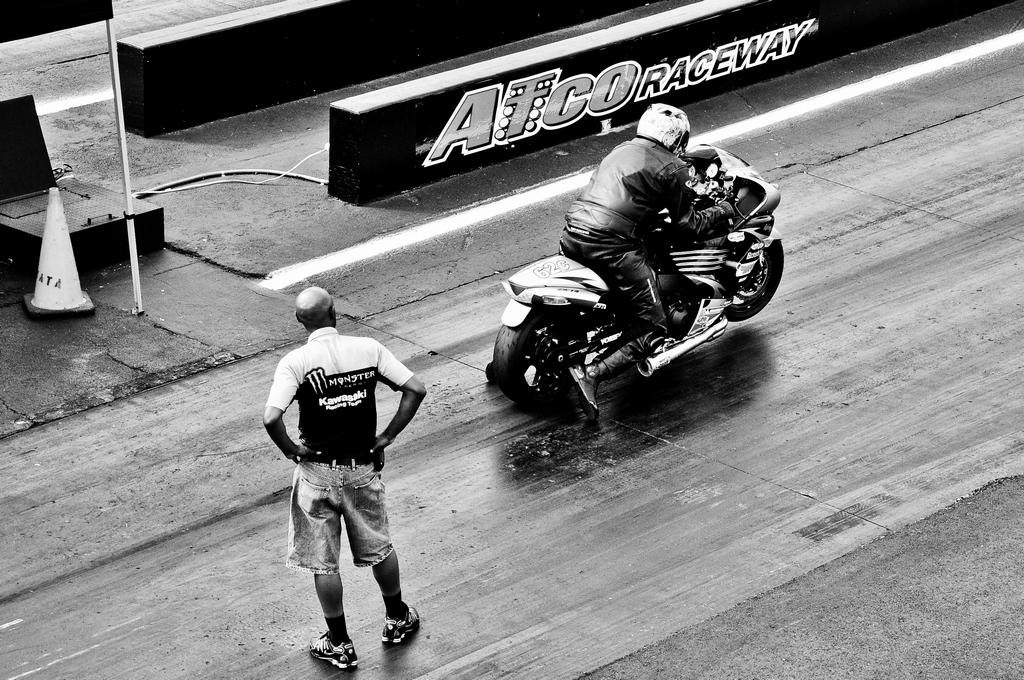What is happening on the road in the image? There is a person standing on the road and another person riding a bike. Can you describe any specific features of the road? There is a manhole on the left side of the road. What type of jeans is the wall wearing in the image? There is no wall or jeans present in the image; it features a person standing on the road and another person riding a bike. 